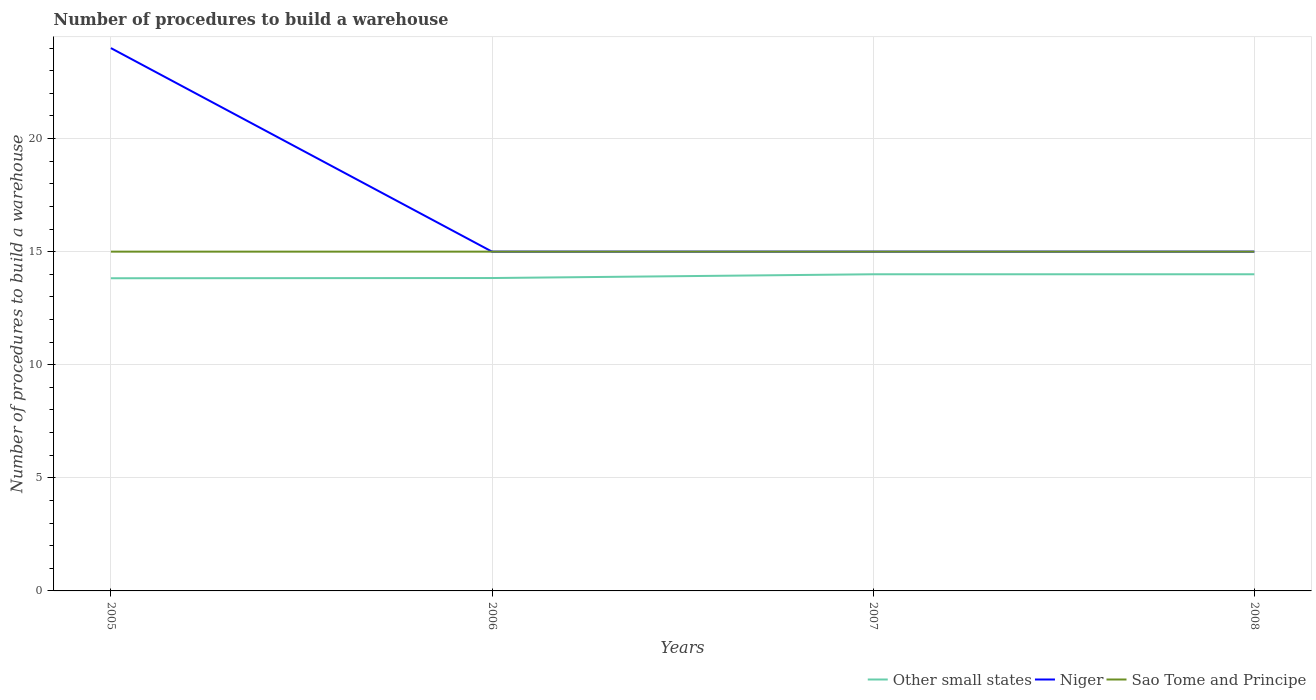How many different coloured lines are there?
Offer a terse response. 3. Across all years, what is the maximum number of procedures to build a warehouse in in Other small states?
Give a very brief answer. 13.82. In which year was the number of procedures to build a warehouse in in Other small states maximum?
Your answer should be very brief. 2005. What is the total number of procedures to build a warehouse in in Other small states in the graph?
Provide a short and direct response. -0.17. What is the difference between the highest and the second highest number of procedures to build a warehouse in in Niger?
Your response must be concise. 9. What is the difference between the highest and the lowest number of procedures to build a warehouse in in Other small states?
Your answer should be very brief. 2. Is the number of procedures to build a warehouse in in Niger strictly greater than the number of procedures to build a warehouse in in Sao Tome and Principe over the years?
Offer a very short reply. No. How many lines are there?
Ensure brevity in your answer.  3. How many years are there in the graph?
Make the answer very short. 4. What is the difference between two consecutive major ticks on the Y-axis?
Your answer should be compact. 5. Does the graph contain any zero values?
Offer a terse response. No. Where does the legend appear in the graph?
Keep it short and to the point. Bottom right. How are the legend labels stacked?
Provide a succinct answer. Horizontal. What is the title of the graph?
Make the answer very short. Number of procedures to build a warehouse. What is the label or title of the X-axis?
Keep it short and to the point. Years. What is the label or title of the Y-axis?
Keep it short and to the point. Number of procedures to build a warehouse. What is the Number of procedures to build a warehouse of Other small states in 2005?
Provide a succinct answer. 13.82. What is the Number of procedures to build a warehouse of Niger in 2005?
Offer a very short reply. 24. What is the Number of procedures to build a warehouse of Sao Tome and Principe in 2005?
Provide a succinct answer. 15. What is the Number of procedures to build a warehouse of Other small states in 2006?
Keep it short and to the point. 13.83. What is the Number of procedures to build a warehouse in Niger in 2006?
Offer a very short reply. 15. What is the Number of procedures to build a warehouse in Sao Tome and Principe in 2007?
Your answer should be compact. 15. What is the Number of procedures to build a warehouse in Niger in 2008?
Keep it short and to the point. 15. Across all years, what is the maximum Number of procedures to build a warehouse in Niger?
Give a very brief answer. 24. Across all years, what is the maximum Number of procedures to build a warehouse of Sao Tome and Principe?
Ensure brevity in your answer.  15. Across all years, what is the minimum Number of procedures to build a warehouse in Other small states?
Keep it short and to the point. 13.82. Across all years, what is the minimum Number of procedures to build a warehouse of Niger?
Provide a succinct answer. 15. What is the total Number of procedures to build a warehouse in Other small states in the graph?
Provide a succinct answer. 55.66. What is the difference between the Number of procedures to build a warehouse of Other small states in 2005 and that in 2006?
Provide a short and direct response. -0.01. What is the difference between the Number of procedures to build a warehouse of Sao Tome and Principe in 2005 and that in 2006?
Your answer should be compact. 0. What is the difference between the Number of procedures to build a warehouse in Other small states in 2005 and that in 2007?
Make the answer very short. -0.18. What is the difference between the Number of procedures to build a warehouse in Niger in 2005 and that in 2007?
Provide a succinct answer. 9. What is the difference between the Number of procedures to build a warehouse in Sao Tome and Principe in 2005 and that in 2007?
Give a very brief answer. 0. What is the difference between the Number of procedures to build a warehouse of Other small states in 2005 and that in 2008?
Provide a short and direct response. -0.18. What is the difference between the Number of procedures to build a warehouse of Sao Tome and Principe in 2005 and that in 2008?
Your response must be concise. 0. What is the difference between the Number of procedures to build a warehouse of Other small states in 2006 and that in 2007?
Ensure brevity in your answer.  -0.17. What is the difference between the Number of procedures to build a warehouse in Sao Tome and Principe in 2006 and that in 2007?
Your response must be concise. 0. What is the difference between the Number of procedures to build a warehouse of Other small states in 2006 and that in 2008?
Your response must be concise. -0.17. What is the difference between the Number of procedures to build a warehouse in Sao Tome and Principe in 2006 and that in 2008?
Offer a very short reply. 0. What is the difference between the Number of procedures to build a warehouse of Niger in 2007 and that in 2008?
Your response must be concise. 0. What is the difference between the Number of procedures to build a warehouse of Other small states in 2005 and the Number of procedures to build a warehouse of Niger in 2006?
Offer a terse response. -1.18. What is the difference between the Number of procedures to build a warehouse of Other small states in 2005 and the Number of procedures to build a warehouse of Sao Tome and Principe in 2006?
Your answer should be very brief. -1.18. What is the difference between the Number of procedures to build a warehouse of Niger in 2005 and the Number of procedures to build a warehouse of Sao Tome and Principe in 2006?
Your answer should be very brief. 9. What is the difference between the Number of procedures to build a warehouse of Other small states in 2005 and the Number of procedures to build a warehouse of Niger in 2007?
Your response must be concise. -1.18. What is the difference between the Number of procedures to build a warehouse in Other small states in 2005 and the Number of procedures to build a warehouse in Sao Tome and Principe in 2007?
Give a very brief answer. -1.18. What is the difference between the Number of procedures to build a warehouse in Other small states in 2005 and the Number of procedures to build a warehouse in Niger in 2008?
Provide a succinct answer. -1.18. What is the difference between the Number of procedures to build a warehouse of Other small states in 2005 and the Number of procedures to build a warehouse of Sao Tome and Principe in 2008?
Offer a very short reply. -1.18. What is the difference between the Number of procedures to build a warehouse of Niger in 2005 and the Number of procedures to build a warehouse of Sao Tome and Principe in 2008?
Give a very brief answer. 9. What is the difference between the Number of procedures to build a warehouse of Other small states in 2006 and the Number of procedures to build a warehouse of Niger in 2007?
Give a very brief answer. -1.17. What is the difference between the Number of procedures to build a warehouse in Other small states in 2006 and the Number of procedures to build a warehouse in Sao Tome and Principe in 2007?
Provide a succinct answer. -1.17. What is the difference between the Number of procedures to build a warehouse in Niger in 2006 and the Number of procedures to build a warehouse in Sao Tome and Principe in 2007?
Your answer should be very brief. 0. What is the difference between the Number of procedures to build a warehouse of Other small states in 2006 and the Number of procedures to build a warehouse of Niger in 2008?
Your answer should be compact. -1.17. What is the difference between the Number of procedures to build a warehouse of Other small states in 2006 and the Number of procedures to build a warehouse of Sao Tome and Principe in 2008?
Give a very brief answer. -1.17. What is the difference between the Number of procedures to build a warehouse in Other small states in 2007 and the Number of procedures to build a warehouse in Sao Tome and Principe in 2008?
Provide a short and direct response. -1. What is the average Number of procedures to build a warehouse of Other small states per year?
Offer a very short reply. 13.91. What is the average Number of procedures to build a warehouse in Niger per year?
Your answer should be compact. 17.25. In the year 2005, what is the difference between the Number of procedures to build a warehouse of Other small states and Number of procedures to build a warehouse of Niger?
Give a very brief answer. -10.18. In the year 2005, what is the difference between the Number of procedures to build a warehouse in Other small states and Number of procedures to build a warehouse in Sao Tome and Principe?
Provide a succinct answer. -1.18. In the year 2005, what is the difference between the Number of procedures to build a warehouse in Niger and Number of procedures to build a warehouse in Sao Tome and Principe?
Provide a short and direct response. 9. In the year 2006, what is the difference between the Number of procedures to build a warehouse in Other small states and Number of procedures to build a warehouse in Niger?
Keep it short and to the point. -1.17. In the year 2006, what is the difference between the Number of procedures to build a warehouse in Other small states and Number of procedures to build a warehouse in Sao Tome and Principe?
Make the answer very short. -1.17. In the year 2007, what is the difference between the Number of procedures to build a warehouse in Other small states and Number of procedures to build a warehouse in Niger?
Ensure brevity in your answer.  -1. In the year 2007, what is the difference between the Number of procedures to build a warehouse of Other small states and Number of procedures to build a warehouse of Sao Tome and Principe?
Your answer should be compact. -1. In the year 2008, what is the difference between the Number of procedures to build a warehouse in Niger and Number of procedures to build a warehouse in Sao Tome and Principe?
Give a very brief answer. 0. What is the ratio of the Number of procedures to build a warehouse of Other small states in 2005 to that in 2006?
Keep it short and to the point. 1. What is the ratio of the Number of procedures to build a warehouse of Other small states in 2005 to that in 2007?
Your answer should be compact. 0.99. What is the ratio of the Number of procedures to build a warehouse of Niger in 2005 to that in 2007?
Your response must be concise. 1.6. What is the ratio of the Number of procedures to build a warehouse in Sao Tome and Principe in 2005 to that in 2007?
Keep it short and to the point. 1. What is the ratio of the Number of procedures to build a warehouse of Other small states in 2005 to that in 2008?
Give a very brief answer. 0.99. What is the ratio of the Number of procedures to build a warehouse in Niger in 2006 to that in 2007?
Your answer should be very brief. 1. What is the ratio of the Number of procedures to build a warehouse of Niger in 2006 to that in 2008?
Your answer should be compact. 1. What is the ratio of the Number of procedures to build a warehouse of Sao Tome and Principe in 2006 to that in 2008?
Ensure brevity in your answer.  1. What is the ratio of the Number of procedures to build a warehouse of Niger in 2007 to that in 2008?
Your answer should be very brief. 1. What is the ratio of the Number of procedures to build a warehouse of Sao Tome and Principe in 2007 to that in 2008?
Your answer should be very brief. 1. What is the difference between the highest and the second highest Number of procedures to build a warehouse of Other small states?
Ensure brevity in your answer.  0. What is the difference between the highest and the second highest Number of procedures to build a warehouse in Sao Tome and Principe?
Your answer should be very brief. 0. What is the difference between the highest and the lowest Number of procedures to build a warehouse of Other small states?
Your response must be concise. 0.18. 